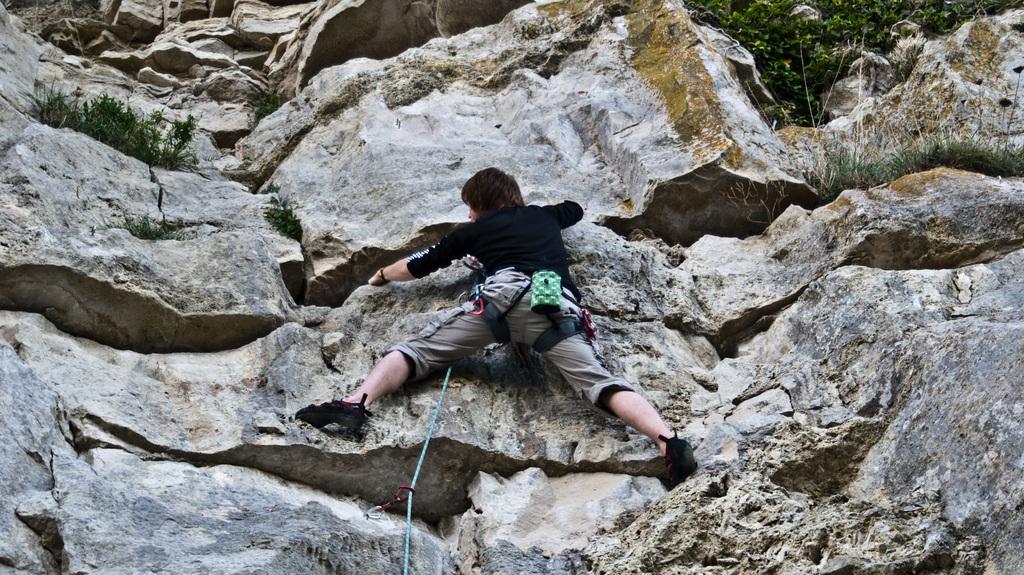Can you describe this image briefly? In this image we can see a person doing rock climbing. In the background we can see plants and grass. 